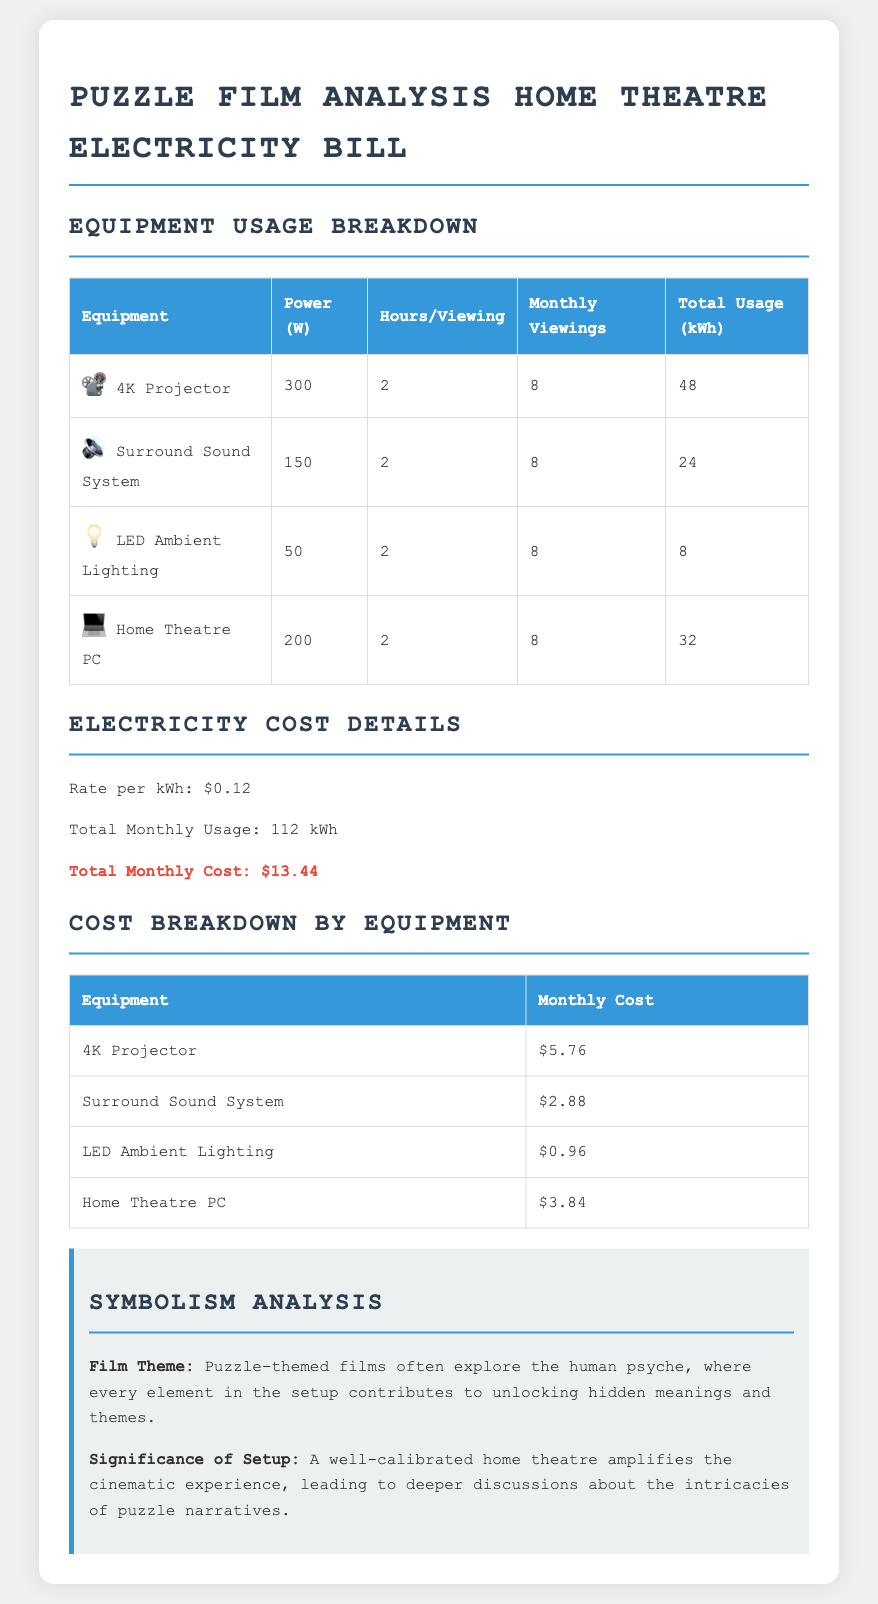what is the total monthly usage in kWh? The total monthly usage is calculated from the sum of all equipment usage, which amounts to 112 kWh.
Answer: 112 kWh what is the rate per kWh? The rate per kWh is specified in the electricity cost details section of the document.
Answer: $0.12 how much does the 4K projector cost monthly? The monthly cost for the 4K projector is given in the cost breakdown by equipment table.
Answer: $5.76 what is the power consumption of the Surround Sound System in W? The power consumption is listed in the equipment usage breakdown table for the Surround Sound System.
Answer: 150 W how many viewings are accounted for in the monthly breakdown? The monthly viewings are specified in the equipment usage breakdown for each device, which is consistent across all equipment.
Answer: 8 what is the total monthly cost? The total monthly cost is calculated based on total usage and rate per kWh provided in the document.
Answer: $13.44 what does the "LED Ambient Lighting" contribute in kWh? The contribution in kWh is listed in the equipment usage breakdown table under the Total Usage column.
Answer: 8 kWh what theme do puzzle-themed films often explore? The film theme described relates to exploring a specific aspect of human experience, as outlined in the symbolism analysis.
Answer: Human psyche how many hours per viewing does the Home Theatre PC operate? The hours per viewing are specified for each piece of equipment in the equipment usage breakdown table.
Answer: 2 